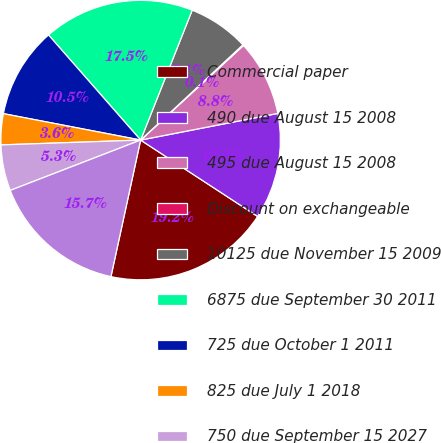<chart> <loc_0><loc_0><loc_500><loc_500><pie_chart><fcel>Commercial paper<fcel>490 due August 15 2008<fcel>495 due August 15 2008<fcel>Discount on exchangeable<fcel>10125 due November 15 2009<fcel>6875 due September 30 2011<fcel>725 due October 1 2011<fcel>825 due July 1 2018<fcel>750 due September 15 2027<fcel>7875 due September 30 2031<nl><fcel>19.2%<fcel>12.26%<fcel>8.78%<fcel>0.1%<fcel>7.05%<fcel>17.47%<fcel>10.52%<fcel>3.58%<fcel>5.31%<fcel>15.73%<nl></chart> 